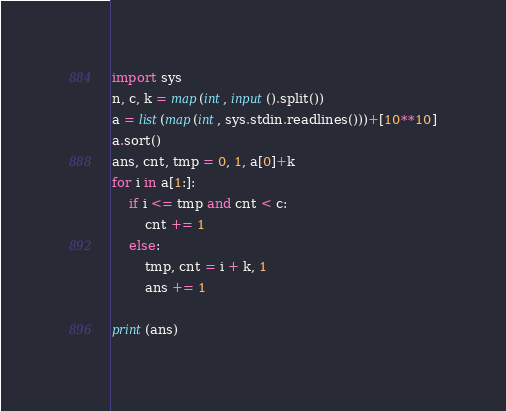<code> <loc_0><loc_0><loc_500><loc_500><_Python_>import sys
n, c, k = map(int, input().split())
a = list(map(int, sys.stdin.readlines()))+[10**10]
a.sort()
ans, cnt, tmp = 0, 1, a[0]+k
for i in a[1:]:
    if i <= tmp and cnt < c:
        cnt += 1
    else:
        tmp, cnt = i + k, 1
        ans += 1

print(ans)</code> 